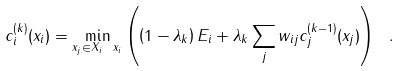Convert formula to latex. <formula><loc_0><loc_0><loc_500><loc_500>c ^ { ( k ) } _ { i } ( x _ { i } ) = \min _ { x _ { j } \in X _ { i } \ { x _ { i } } } \left ( \left ( 1 - \lambda _ { k } \right ) E _ { i } + \lambda _ { k } \sum _ { j } w _ { i j } c ^ { ( k - 1 ) } _ { j } ( x _ { j } ) \right ) \ .</formula> 